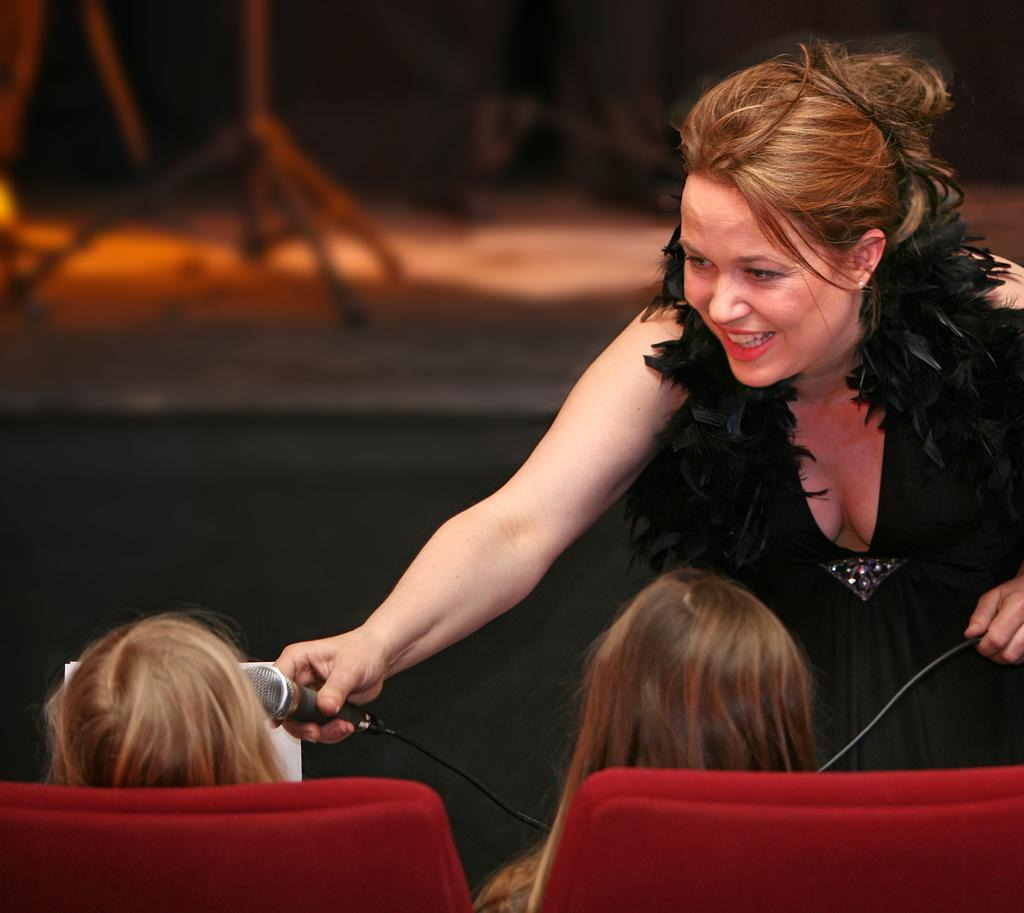What is the lady in the image holding? The lady is holding a mic in the image. What is the lady wearing? The lady is wearing a black dress. What expression does the lady have? The lady is smiling. Who else is present in the image? There are two people sitting on chairs in the foreground. What can be seen in the background of the image? There is a stage in the background. What type of scarf is the lady wearing in the image? The lady is not wearing a scarf in the image. 